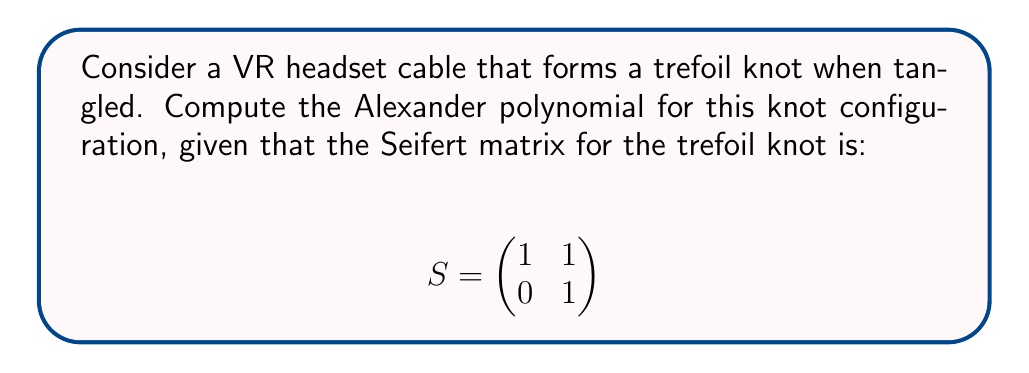Show me your answer to this math problem. To compute the Alexander polynomial for the trefoil knot representing the VR headset cable, we'll follow these steps:

1. Recall the formula for the Alexander polynomial using the Seifert matrix:
   $$\Delta(t) = \det(tS - S^T)$$
   where $S$ is the Seifert matrix and $S^T$ is its transpose.

2. Calculate $S^T$:
   $$S^T = \begin{pmatrix}
   1 & 0 \\
   1 & 1
   \end{pmatrix}$$

3. Compute $tS$:
   $$tS = \begin{pmatrix}
   t & t \\
   0 & t
   \end{pmatrix}$$

4. Calculate $tS - S^T$:
   $$tS - S^T = \begin{pmatrix}
   t & t \\
   0 & t
   \end{pmatrix} - \begin{pmatrix}
   1 & 0 \\
   1 & 1
   \end{pmatrix} = \begin{pmatrix}
   t-1 & t \\
   -1 & t-1
   \end{pmatrix}$$

5. Compute the determinant of $tS - S^T$:
   $$\det(tS - S^T) = \det\begin{pmatrix}
   t-1 & t \\
   -1 & t-1
   \end{pmatrix}$$
   $$= (t-1)(t-1) - (-1)(t)$$
   $$= t^2 - 2t + 1 + t$$
   $$= t^2 - t + 1$$

Therefore, the Alexander polynomial for the trefoil knot representing the VR headset cable is $t^2 - t + 1$.
Answer: $t^2 - t + 1$ 